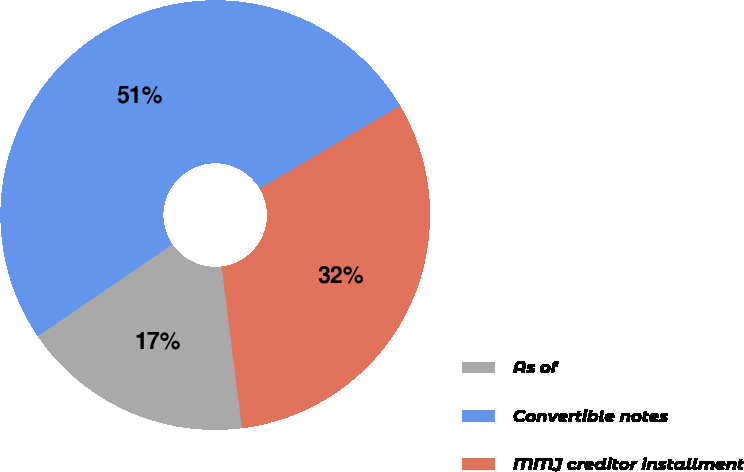Convert chart. <chart><loc_0><loc_0><loc_500><loc_500><pie_chart><fcel>As of<fcel>Convertible notes<fcel>MMJ creditor installment<nl><fcel>17.46%<fcel>51.03%<fcel>31.51%<nl></chart> 